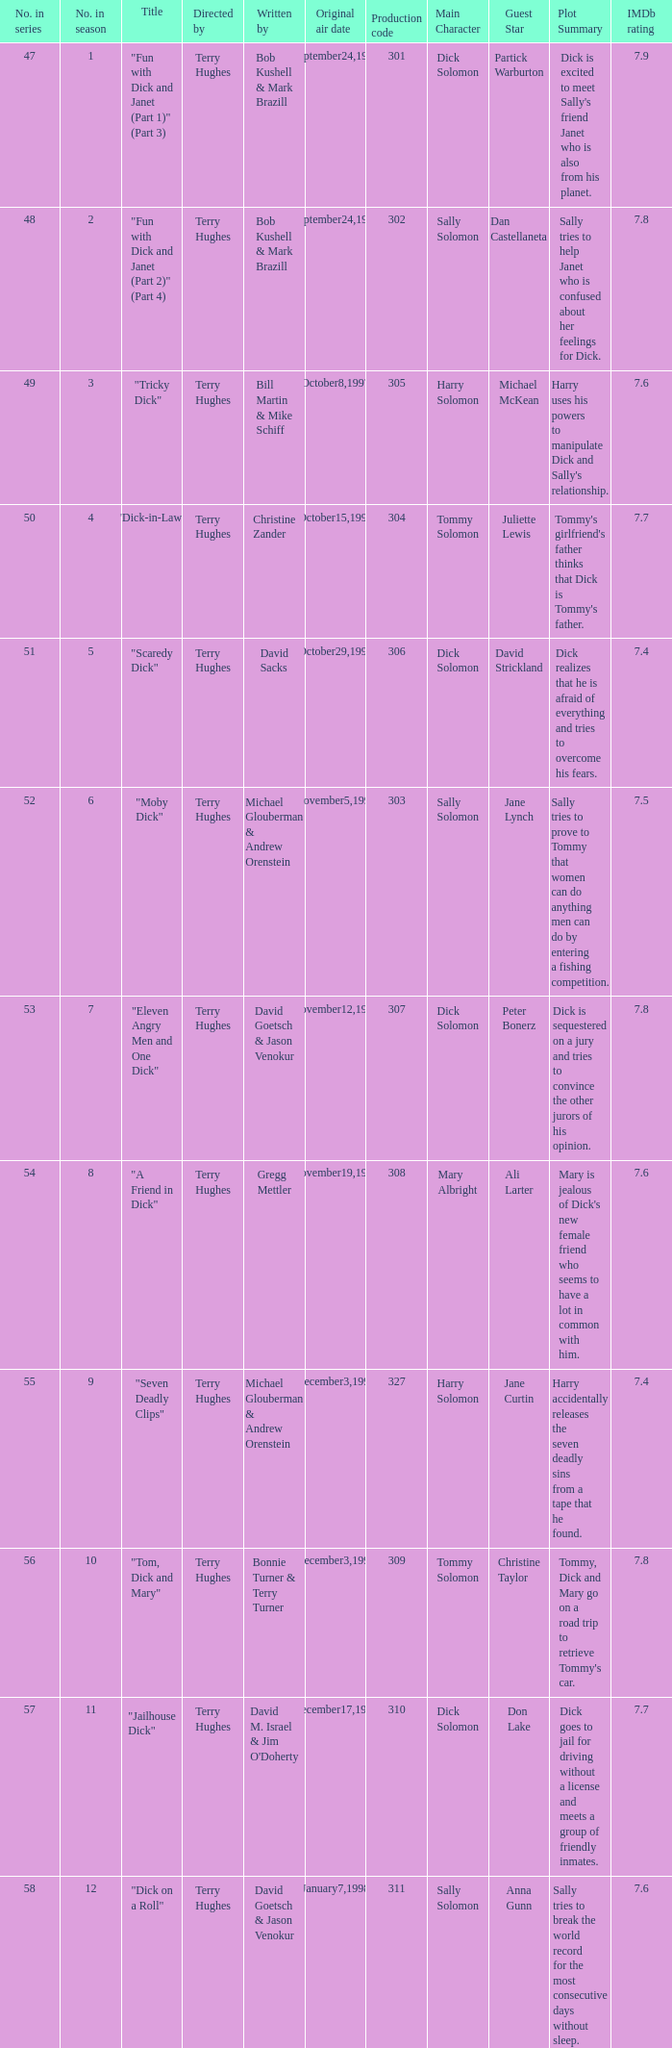Who were the writers of the episode titled "Tricky Dick"? Bill Martin & Mike Schiff. Could you parse the entire table? {'header': ['No. in series', 'No. in season', 'Title', 'Directed by', 'Written by', 'Original air date', 'Production code', 'Main Character', 'Guest Star', 'Plot Summary', 'IMDb rating'], 'rows': [['47', '1', '"Fun with Dick and Janet (Part 1)" (Part 3)', 'Terry Hughes', 'Bob Kushell & Mark Brazill', 'September24,1997', '301', 'Dick Solomon', 'Partick Warburton', "Dick is excited to meet Sally's friend Janet who is also from his planet.", '7.9'], ['48', '2', '"Fun with Dick and Janet (Part 2)" (Part 4)', 'Terry Hughes', 'Bob Kushell & Mark Brazill', 'September24,1997', '302', 'Sally Solomon', 'Dan Castellaneta', 'Sally tries to help Janet who is confused about her feelings for Dick.', '7.8'], ['49', '3', '"Tricky Dick"', 'Terry Hughes', 'Bill Martin & Mike Schiff', 'October8,1997', '305', 'Harry Solomon', 'Michael McKean', "Harry uses his powers to manipulate Dick and Sally's relationship.", '7.6'], ['50', '4', '"Dick-in-Law"', 'Terry Hughes', 'Christine Zander', 'October15,1997', '304', 'Tommy Solomon', 'Juliette Lewis', "Tommy's girlfriend's father thinks that Dick is Tommy's father.", '7.7'], ['51', '5', '"Scaredy Dick"', 'Terry Hughes', 'David Sacks', 'October29,1997', '306', 'Dick Solomon', 'David Strickland', 'Dick realizes that he is afraid of everything and tries to overcome his fears.', '7.4'], ['52', '6', '"Moby Dick"', 'Terry Hughes', 'Michael Glouberman & Andrew Orenstein', 'November5,1997', '303', 'Sally Solomon', 'Jane Lynch', 'Sally tries to prove to Tommy that women can do anything men can do by entering a fishing competition.', '7.5'], ['53', '7', '"Eleven Angry Men and One Dick"', 'Terry Hughes', 'David Goetsch & Jason Venokur', 'November12,1997', '307', 'Dick Solomon', 'Peter Bonerz', 'Dick is sequestered on a jury and tries to convince the other jurors of his opinion.', '7.8'], ['54', '8', '"A Friend in Dick"', 'Terry Hughes', 'Gregg Mettler', 'November19,1997', '308', 'Mary Albright', 'Ali Larter', "Mary is jealous of Dick's new female friend who seems to have a lot in common with him.", '7.6'], ['55', '9', '"Seven Deadly Clips"', 'Terry Hughes', 'Michael Glouberman & Andrew Orenstein', 'December3,1997', '327', 'Harry Solomon', 'Jane Curtin', 'Harry accidentally releases the seven deadly sins from a tape that he found.', '7.4'], ['56', '10', '"Tom, Dick and Mary"', 'Terry Hughes', 'Bonnie Turner & Terry Turner', 'December3,1997', '309', 'Tommy Solomon', 'Christine Taylor', "Tommy, Dick and Mary go on a road trip to retrieve Tommy's car.", '7.8'], ['57', '11', '"Jailhouse Dick"', 'Terry Hughes', "David M. Israel & Jim O'Doherty", 'December17,1997', '310', 'Dick Solomon', 'Don Lake', 'Dick goes to jail for driving without a license and meets a group of friendly inmates.', '7.7'], ['58', '12', '"Dick on a Roll"', 'Terry Hughes', 'David Goetsch & Jason Venokur', 'January7,1998', '311', 'Sally Solomon', 'Anna Gunn', 'Sally tries to break the world record for the most consecutive days without sleep.', '7.6'], ['59', '13', '"The Great Dickdater"', 'Terry Hughes', 'David Sacks', 'January21,1998', '312', 'Dick Solomon', "Tim O'Connor", "Albright's father tries to set Mary up on a date with a wealthy businessman.", '7.7'], ['60', '14', '"36! 24! 36! Dick (Part 1)"', 'Terry Hughes', 'Bill Martin & Mike Schiff & Christine Zander', 'January25,1998', '313', 'Harry Solomon', 'Dorien Wilson', "Harry creates a robot girlfriend named Vicki who takes over the Solomons' house.", '7.6'], ['61', '15', '"36! 24! 36! Dick (Part 2)"', 'Terry Hughes', 'Bill Martin & Mike Schiff & Christine Zander', 'January25,1998', '314', 'Sally Solomon', 'Tracy Nelson', 'Sally and Mary try to outdo each other in a beauty pageant.', '7.5'], ['62', '16', '"Pickles and Ice Cream"', 'Terry Hughes', 'Bob Kushell', 'January28,1998', '315', 'Dick Solomon', 'Jonathan Frakes', 'Dick becomes obsessed with pickles and ice cream after learning about human pregnancy cravings.', '7.4'], ['63', '17', '"Auto Eurodicka"', 'Terry Hughes', 'Mark Brazill', 'February4,1998', '316', 'Tommy Solomon', 'John Corbett', 'Tommy gets a job as a mechanic and meets a beautiful customer.', '7.8'], ['64', '18', '"Portrait of Tommy as an Old Man"', 'Terry Hughes', 'Bob Kushell & Gregg Mettler', 'February25,1998', '317', 'Tommy Solomon', 'Jim Beaver', 'Tommy discovers that he has a rare genetic condition that will cause him to age rapidly.', '7.6'], ['65', '19', '"Stuck with Dick"', 'Terry Hughes', "Jim O'Doherty & David M. Israel", 'March18,1998', '318', 'Dick Solomon', 'Katie Finneran', 'Dick becomes stuck in a wall while trying to fix a leak.', '7.7'], ['66', '20', '"My Daddy\'s Little Girl"', 'Terry Hughes', 'Christine Zander & Mark Brazill', 'April1,1998', '319', 'Sally Solomon', 'Marlo Thomas', "Sally's father comes to visit and tries to convince her to come back home.", '7.6'], ['67', '21', '"The Physics of Being Dick"', 'Terry Hughes', 'David Schiff', 'April15,1998', '323', 'Dick Solomon', 'Matt Roth', "Dick's old college roommate comes to visit and tries to convince him to return to their old college.", '7.4'], ['68', '22', '"Just Your Average Dick" (Part 1)', 'Terry Hughes', 'Michael Glouberman & Andrew Orenstein', 'April28,1998', '320', 'Harry Solomon', 'Wayne Knight', 'Harry becomes convinced that he is an alien spy and tries to complete his mission.', '7.9'], ['69', '23', '"Dick and the Other Guy" (Part 2)', 'Terry Hughes', 'Bonnie Turner & Terry Turner', 'April28,1998', '321', 'Sally Solomon', 'Jane Kaczmarek', "Mary accidentally kisses Dick's evil twin brother.", '7.8'], ['70', '24', '"Sally and Don\'s First Kiss"', 'Terry Hughes', 'David Sacks', 'May6,1998', '322', 'Sally Solomon', 'Michael Ensign', "Sally's boss asks her out on a date.", '7.7'], ['71', '25', '"When Aliens Camp"', 'Terry Hughes', "David M. Israel & Jim O'Doherty", 'May13,1998', '324', 'Tommy Solomon', 'Chris Hogan', "The Solomons go on a camping trip with Mary's family.", '7.6'], ['72', '26', '"The Tooth Harry"', 'Terry Hughes', 'Joshua Sternin & Jeffrey Ventimilia', 'May20,1998', '325', 'Harry Solomon', 'Ben Stein', 'Harry tries to help a young boy who is afraid of going to the dentist.', '7.8']]} 